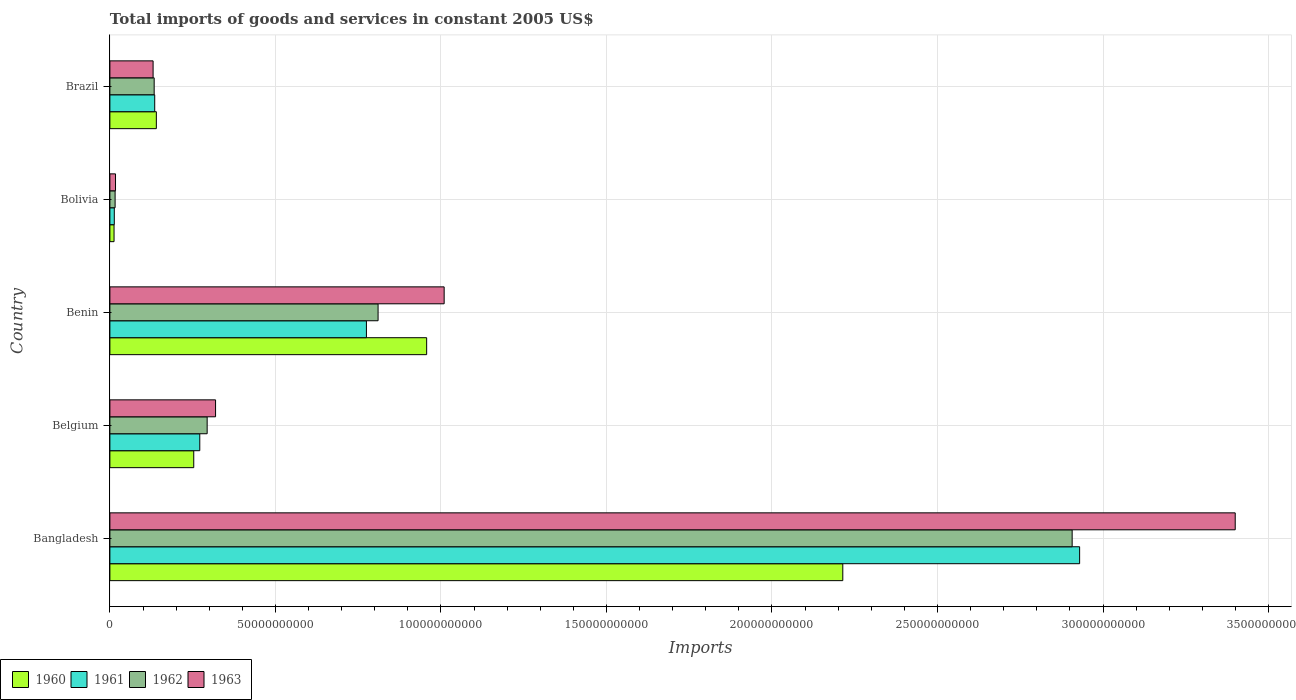How many different coloured bars are there?
Your response must be concise. 4. How many bars are there on the 2nd tick from the bottom?
Give a very brief answer. 4. What is the label of the 1st group of bars from the top?
Give a very brief answer. Brazil. What is the total imports of goods and services in 1963 in Brazil?
Make the answer very short. 1.31e+1. Across all countries, what is the maximum total imports of goods and services in 1962?
Your answer should be compact. 2.91e+11. Across all countries, what is the minimum total imports of goods and services in 1961?
Your answer should be compact. 1.33e+09. In which country was the total imports of goods and services in 1962 maximum?
Offer a terse response. Bangladesh. What is the total total imports of goods and services in 1961 in the graph?
Your response must be concise. 4.12e+11. What is the difference between the total imports of goods and services in 1963 in Belgium and that in Brazil?
Offer a terse response. 1.89e+1. What is the difference between the total imports of goods and services in 1961 in Brazil and the total imports of goods and services in 1962 in Belgium?
Provide a short and direct response. -1.58e+1. What is the average total imports of goods and services in 1961 per country?
Ensure brevity in your answer.  8.25e+1. What is the difference between the total imports of goods and services in 1962 and total imports of goods and services in 1961 in Bolivia?
Your response must be concise. 2.45e+08. What is the ratio of the total imports of goods and services in 1963 in Belgium to that in Brazil?
Your answer should be compact. 2.45. Is the total imports of goods and services in 1960 in Bangladesh less than that in Belgium?
Offer a terse response. No. What is the difference between the highest and the second highest total imports of goods and services in 1962?
Make the answer very short. 2.10e+11. What is the difference between the highest and the lowest total imports of goods and services in 1960?
Provide a short and direct response. 2.20e+11. In how many countries, is the total imports of goods and services in 1963 greater than the average total imports of goods and services in 1963 taken over all countries?
Offer a terse response. 2. Is it the case that in every country, the sum of the total imports of goods and services in 1962 and total imports of goods and services in 1961 is greater than the sum of total imports of goods and services in 1963 and total imports of goods and services in 1960?
Your response must be concise. No. What does the 4th bar from the bottom in Belgium represents?
Ensure brevity in your answer.  1963. Is it the case that in every country, the sum of the total imports of goods and services in 1961 and total imports of goods and services in 1962 is greater than the total imports of goods and services in 1960?
Ensure brevity in your answer.  Yes. Are all the bars in the graph horizontal?
Your response must be concise. Yes. How many countries are there in the graph?
Offer a very short reply. 5. What is the difference between two consecutive major ticks on the X-axis?
Provide a short and direct response. 5.00e+1. Does the graph contain any zero values?
Offer a terse response. No. How many legend labels are there?
Your answer should be compact. 4. How are the legend labels stacked?
Provide a succinct answer. Horizontal. What is the title of the graph?
Offer a very short reply. Total imports of goods and services in constant 2005 US$. What is the label or title of the X-axis?
Your response must be concise. Imports. What is the label or title of the Y-axis?
Offer a very short reply. Country. What is the Imports in 1960 in Bangladesh?
Make the answer very short. 2.21e+11. What is the Imports in 1961 in Bangladesh?
Your answer should be very brief. 2.93e+11. What is the Imports of 1962 in Bangladesh?
Offer a very short reply. 2.91e+11. What is the Imports of 1963 in Bangladesh?
Ensure brevity in your answer.  3.40e+11. What is the Imports of 1960 in Belgium?
Your answer should be compact. 2.53e+1. What is the Imports in 1961 in Belgium?
Your response must be concise. 2.72e+1. What is the Imports in 1962 in Belgium?
Ensure brevity in your answer.  2.94e+1. What is the Imports of 1963 in Belgium?
Provide a short and direct response. 3.19e+1. What is the Imports in 1960 in Benin?
Keep it short and to the point. 9.57e+1. What is the Imports in 1961 in Benin?
Offer a very short reply. 7.75e+1. What is the Imports of 1962 in Benin?
Give a very brief answer. 8.10e+1. What is the Imports of 1963 in Benin?
Keep it short and to the point. 1.01e+11. What is the Imports in 1960 in Bolivia?
Give a very brief answer. 1.26e+09. What is the Imports of 1961 in Bolivia?
Your answer should be compact. 1.33e+09. What is the Imports of 1962 in Bolivia?
Your answer should be compact. 1.58e+09. What is the Imports of 1963 in Bolivia?
Keep it short and to the point. 1.70e+09. What is the Imports in 1960 in Brazil?
Make the answer very short. 1.40e+1. What is the Imports in 1961 in Brazil?
Keep it short and to the point. 1.35e+1. What is the Imports of 1962 in Brazil?
Provide a short and direct response. 1.34e+1. What is the Imports of 1963 in Brazil?
Keep it short and to the point. 1.31e+1. Across all countries, what is the maximum Imports in 1960?
Your response must be concise. 2.21e+11. Across all countries, what is the maximum Imports of 1961?
Provide a short and direct response. 2.93e+11. Across all countries, what is the maximum Imports in 1962?
Ensure brevity in your answer.  2.91e+11. Across all countries, what is the maximum Imports of 1963?
Offer a terse response. 3.40e+11. Across all countries, what is the minimum Imports in 1960?
Ensure brevity in your answer.  1.26e+09. Across all countries, what is the minimum Imports of 1961?
Your answer should be very brief. 1.33e+09. Across all countries, what is the minimum Imports of 1962?
Provide a short and direct response. 1.58e+09. Across all countries, what is the minimum Imports of 1963?
Make the answer very short. 1.70e+09. What is the total Imports of 1960 in the graph?
Provide a short and direct response. 3.58e+11. What is the total Imports in 1961 in the graph?
Offer a very short reply. 4.12e+11. What is the total Imports in 1962 in the graph?
Offer a terse response. 4.16e+11. What is the total Imports of 1963 in the graph?
Your response must be concise. 4.88e+11. What is the difference between the Imports in 1960 in Bangladesh and that in Belgium?
Keep it short and to the point. 1.96e+11. What is the difference between the Imports in 1961 in Bangladesh and that in Belgium?
Make the answer very short. 2.66e+11. What is the difference between the Imports in 1962 in Bangladesh and that in Belgium?
Offer a terse response. 2.61e+11. What is the difference between the Imports of 1963 in Bangladesh and that in Belgium?
Your answer should be very brief. 3.08e+11. What is the difference between the Imports in 1960 in Bangladesh and that in Benin?
Your answer should be compact. 1.26e+11. What is the difference between the Imports in 1961 in Bangladesh and that in Benin?
Make the answer very short. 2.15e+11. What is the difference between the Imports of 1962 in Bangladesh and that in Benin?
Your answer should be compact. 2.10e+11. What is the difference between the Imports in 1963 in Bangladesh and that in Benin?
Offer a very short reply. 2.39e+11. What is the difference between the Imports in 1960 in Bangladesh and that in Bolivia?
Offer a terse response. 2.20e+11. What is the difference between the Imports in 1961 in Bangladesh and that in Bolivia?
Your response must be concise. 2.92e+11. What is the difference between the Imports in 1962 in Bangladesh and that in Bolivia?
Provide a succinct answer. 2.89e+11. What is the difference between the Imports in 1963 in Bangladesh and that in Bolivia?
Provide a short and direct response. 3.38e+11. What is the difference between the Imports of 1960 in Bangladesh and that in Brazil?
Keep it short and to the point. 2.07e+11. What is the difference between the Imports of 1961 in Bangladesh and that in Brazil?
Make the answer very short. 2.79e+11. What is the difference between the Imports of 1962 in Bangladesh and that in Brazil?
Make the answer very short. 2.77e+11. What is the difference between the Imports of 1963 in Bangladesh and that in Brazil?
Offer a very short reply. 3.27e+11. What is the difference between the Imports of 1960 in Belgium and that in Benin?
Offer a terse response. -7.04e+1. What is the difference between the Imports of 1961 in Belgium and that in Benin?
Keep it short and to the point. -5.03e+1. What is the difference between the Imports in 1962 in Belgium and that in Benin?
Offer a terse response. -5.16e+1. What is the difference between the Imports in 1963 in Belgium and that in Benin?
Provide a short and direct response. -6.90e+1. What is the difference between the Imports in 1960 in Belgium and that in Bolivia?
Your answer should be very brief. 2.41e+1. What is the difference between the Imports of 1961 in Belgium and that in Bolivia?
Offer a terse response. 2.58e+1. What is the difference between the Imports in 1962 in Belgium and that in Bolivia?
Ensure brevity in your answer.  2.78e+1. What is the difference between the Imports in 1963 in Belgium and that in Bolivia?
Keep it short and to the point. 3.02e+1. What is the difference between the Imports in 1960 in Belgium and that in Brazil?
Your response must be concise. 1.13e+1. What is the difference between the Imports in 1961 in Belgium and that in Brazil?
Provide a short and direct response. 1.36e+1. What is the difference between the Imports in 1962 in Belgium and that in Brazil?
Make the answer very short. 1.60e+1. What is the difference between the Imports of 1963 in Belgium and that in Brazil?
Provide a succinct answer. 1.89e+1. What is the difference between the Imports of 1960 in Benin and that in Bolivia?
Offer a terse response. 9.44e+1. What is the difference between the Imports in 1961 in Benin and that in Bolivia?
Ensure brevity in your answer.  7.62e+1. What is the difference between the Imports of 1962 in Benin and that in Bolivia?
Keep it short and to the point. 7.94e+1. What is the difference between the Imports in 1963 in Benin and that in Bolivia?
Your answer should be compact. 9.93e+1. What is the difference between the Imports in 1960 in Benin and that in Brazil?
Ensure brevity in your answer.  8.17e+1. What is the difference between the Imports in 1961 in Benin and that in Brazil?
Offer a very short reply. 6.39e+1. What is the difference between the Imports in 1962 in Benin and that in Brazil?
Offer a terse response. 6.76e+1. What is the difference between the Imports of 1963 in Benin and that in Brazil?
Your answer should be very brief. 8.79e+1. What is the difference between the Imports of 1960 in Bolivia and that in Brazil?
Your answer should be compact. -1.28e+1. What is the difference between the Imports of 1961 in Bolivia and that in Brazil?
Provide a succinct answer. -1.22e+1. What is the difference between the Imports in 1962 in Bolivia and that in Brazil?
Ensure brevity in your answer.  -1.18e+1. What is the difference between the Imports in 1963 in Bolivia and that in Brazil?
Your response must be concise. -1.14e+1. What is the difference between the Imports in 1960 in Bangladesh and the Imports in 1961 in Belgium?
Give a very brief answer. 1.94e+11. What is the difference between the Imports of 1960 in Bangladesh and the Imports of 1962 in Belgium?
Provide a short and direct response. 1.92e+11. What is the difference between the Imports in 1960 in Bangladesh and the Imports in 1963 in Belgium?
Your answer should be compact. 1.89e+11. What is the difference between the Imports in 1961 in Bangladesh and the Imports in 1962 in Belgium?
Offer a very short reply. 2.64e+11. What is the difference between the Imports in 1961 in Bangladesh and the Imports in 1963 in Belgium?
Offer a terse response. 2.61e+11. What is the difference between the Imports of 1962 in Bangladesh and the Imports of 1963 in Belgium?
Offer a terse response. 2.59e+11. What is the difference between the Imports in 1960 in Bangladesh and the Imports in 1961 in Benin?
Make the answer very short. 1.44e+11. What is the difference between the Imports of 1960 in Bangladesh and the Imports of 1962 in Benin?
Your response must be concise. 1.40e+11. What is the difference between the Imports of 1960 in Bangladesh and the Imports of 1963 in Benin?
Provide a short and direct response. 1.20e+11. What is the difference between the Imports of 1961 in Bangladesh and the Imports of 1962 in Benin?
Offer a very short reply. 2.12e+11. What is the difference between the Imports of 1961 in Bangladesh and the Imports of 1963 in Benin?
Keep it short and to the point. 1.92e+11. What is the difference between the Imports of 1962 in Bangladesh and the Imports of 1963 in Benin?
Offer a very short reply. 1.90e+11. What is the difference between the Imports of 1960 in Bangladesh and the Imports of 1961 in Bolivia?
Provide a succinct answer. 2.20e+11. What is the difference between the Imports of 1960 in Bangladesh and the Imports of 1962 in Bolivia?
Provide a succinct answer. 2.20e+11. What is the difference between the Imports of 1960 in Bangladesh and the Imports of 1963 in Bolivia?
Your answer should be compact. 2.20e+11. What is the difference between the Imports in 1961 in Bangladesh and the Imports in 1962 in Bolivia?
Keep it short and to the point. 2.91e+11. What is the difference between the Imports in 1961 in Bangladesh and the Imports in 1963 in Bolivia?
Keep it short and to the point. 2.91e+11. What is the difference between the Imports in 1962 in Bangladesh and the Imports in 1963 in Bolivia?
Offer a terse response. 2.89e+11. What is the difference between the Imports of 1960 in Bangladesh and the Imports of 1961 in Brazil?
Make the answer very short. 2.08e+11. What is the difference between the Imports of 1960 in Bangladesh and the Imports of 1962 in Brazil?
Offer a very short reply. 2.08e+11. What is the difference between the Imports of 1960 in Bangladesh and the Imports of 1963 in Brazil?
Ensure brevity in your answer.  2.08e+11. What is the difference between the Imports of 1961 in Bangladesh and the Imports of 1962 in Brazil?
Provide a succinct answer. 2.80e+11. What is the difference between the Imports of 1961 in Bangladesh and the Imports of 1963 in Brazil?
Give a very brief answer. 2.80e+11. What is the difference between the Imports in 1962 in Bangladesh and the Imports in 1963 in Brazil?
Provide a short and direct response. 2.78e+11. What is the difference between the Imports of 1960 in Belgium and the Imports of 1961 in Benin?
Your answer should be compact. -5.22e+1. What is the difference between the Imports in 1960 in Belgium and the Imports in 1962 in Benin?
Keep it short and to the point. -5.57e+1. What is the difference between the Imports in 1960 in Belgium and the Imports in 1963 in Benin?
Your answer should be compact. -7.56e+1. What is the difference between the Imports of 1961 in Belgium and the Imports of 1962 in Benin?
Your answer should be compact. -5.39e+1. What is the difference between the Imports in 1961 in Belgium and the Imports in 1963 in Benin?
Keep it short and to the point. -7.38e+1. What is the difference between the Imports in 1962 in Belgium and the Imports in 1963 in Benin?
Keep it short and to the point. -7.16e+1. What is the difference between the Imports of 1960 in Belgium and the Imports of 1961 in Bolivia?
Keep it short and to the point. 2.40e+1. What is the difference between the Imports in 1960 in Belgium and the Imports in 1962 in Bolivia?
Provide a succinct answer. 2.38e+1. What is the difference between the Imports of 1960 in Belgium and the Imports of 1963 in Bolivia?
Provide a short and direct response. 2.36e+1. What is the difference between the Imports in 1961 in Belgium and the Imports in 1962 in Bolivia?
Your answer should be very brief. 2.56e+1. What is the difference between the Imports of 1961 in Belgium and the Imports of 1963 in Bolivia?
Offer a terse response. 2.55e+1. What is the difference between the Imports in 1962 in Belgium and the Imports in 1963 in Bolivia?
Keep it short and to the point. 2.77e+1. What is the difference between the Imports of 1960 in Belgium and the Imports of 1961 in Brazil?
Offer a terse response. 1.18e+1. What is the difference between the Imports of 1960 in Belgium and the Imports of 1962 in Brazil?
Provide a short and direct response. 1.20e+1. What is the difference between the Imports of 1960 in Belgium and the Imports of 1963 in Brazil?
Your answer should be very brief. 1.23e+1. What is the difference between the Imports of 1961 in Belgium and the Imports of 1962 in Brazil?
Give a very brief answer. 1.38e+1. What is the difference between the Imports of 1961 in Belgium and the Imports of 1963 in Brazil?
Keep it short and to the point. 1.41e+1. What is the difference between the Imports of 1962 in Belgium and the Imports of 1963 in Brazil?
Provide a short and direct response. 1.63e+1. What is the difference between the Imports of 1960 in Benin and the Imports of 1961 in Bolivia?
Offer a very short reply. 9.44e+1. What is the difference between the Imports in 1960 in Benin and the Imports in 1962 in Bolivia?
Keep it short and to the point. 9.41e+1. What is the difference between the Imports of 1960 in Benin and the Imports of 1963 in Bolivia?
Keep it short and to the point. 9.40e+1. What is the difference between the Imports of 1961 in Benin and the Imports of 1962 in Bolivia?
Provide a short and direct response. 7.59e+1. What is the difference between the Imports of 1961 in Benin and the Imports of 1963 in Bolivia?
Give a very brief answer. 7.58e+1. What is the difference between the Imports in 1962 in Benin and the Imports in 1963 in Bolivia?
Provide a succinct answer. 7.93e+1. What is the difference between the Imports of 1960 in Benin and the Imports of 1961 in Brazil?
Offer a very short reply. 8.21e+1. What is the difference between the Imports in 1960 in Benin and the Imports in 1962 in Brazil?
Give a very brief answer. 8.23e+1. What is the difference between the Imports in 1960 in Benin and the Imports in 1963 in Brazil?
Give a very brief answer. 8.26e+1. What is the difference between the Imports in 1961 in Benin and the Imports in 1962 in Brazil?
Your answer should be compact. 6.41e+1. What is the difference between the Imports of 1961 in Benin and the Imports of 1963 in Brazil?
Your response must be concise. 6.44e+1. What is the difference between the Imports of 1962 in Benin and the Imports of 1963 in Brazil?
Give a very brief answer. 6.80e+1. What is the difference between the Imports in 1960 in Bolivia and the Imports in 1961 in Brazil?
Your answer should be compact. -1.23e+1. What is the difference between the Imports of 1960 in Bolivia and the Imports of 1962 in Brazil?
Give a very brief answer. -1.21e+1. What is the difference between the Imports in 1960 in Bolivia and the Imports in 1963 in Brazil?
Give a very brief answer. -1.18e+1. What is the difference between the Imports of 1961 in Bolivia and the Imports of 1962 in Brazil?
Give a very brief answer. -1.20e+1. What is the difference between the Imports of 1961 in Bolivia and the Imports of 1963 in Brazil?
Your answer should be very brief. -1.17e+1. What is the difference between the Imports of 1962 in Bolivia and the Imports of 1963 in Brazil?
Offer a very short reply. -1.15e+1. What is the average Imports in 1960 per country?
Offer a terse response. 7.15e+1. What is the average Imports of 1961 per country?
Ensure brevity in your answer.  8.25e+1. What is the average Imports of 1962 per country?
Your response must be concise. 8.32e+1. What is the average Imports in 1963 per country?
Provide a short and direct response. 9.75e+1. What is the difference between the Imports in 1960 and Imports in 1961 in Bangladesh?
Make the answer very short. -7.15e+1. What is the difference between the Imports of 1960 and Imports of 1962 in Bangladesh?
Give a very brief answer. -6.93e+1. What is the difference between the Imports of 1960 and Imports of 1963 in Bangladesh?
Keep it short and to the point. -1.19e+11. What is the difference between the Imports in 1961 and Imports in 1962 in Bangladesh?
Offer a very short reply. 2.26e+09. What is the difference between the Imports of 1961 and Imports of 1963 in Bangladesh?
Offer a terse response. -4.70e+1. What is the difference between the Imports of 1962 and Imports of 1963 in Bangladesh?
Offer a terse response. -4.93e+1. What is the difference between the Imports in 1960 and Imports in 1961 in Belgium?
Give a very brief answer. -1.82e+09. What is the difference between the Imports of 1960 and Imports of 1962 in Belgium?
Ensure brevity in your answer.  -4.05e+09. What is the difference between the Imports of 1960 and Imports of 1963 in Belgium?
Make the answer very short. -6.59e+09. What is the difference between the Imports of 1961 and Imports of 1962 in Belgium?
Your response must be concise. -2.23e+09. What is the difference between the Imports of 1961 and Imports of 1963 in Belgium?
Keep it short and to the point. -4.77e+09. What is the difference between the Imports in 1962 and Imports in 1963 in Belgium?
Provide a succinct answer. -2.54e+09. What is the difference between the Imports in 1960 and Imports in 1961 in Benin?
Offer a terse response. 1.82e+1. What is the difference between the Imports in 1960 and Imports in 1962 in Benin?
Provide a succinct answer. 1.47e+1. What is the difference between the Imports in 1960 and Imports in 1963 in Benin?
Provide a succinct answer. -5.28e+09. What is the difference between the Imports in 1961 and Imports in 1962 in Benin?
Provide a short and direct response. -3.52e+09. What is the difference between the Imports of 1961 and Imports of 1963 in Benin?
Offer a very short reply. -2.35e+1. What is the difference between the Imports of 1962 and Imports of 1963 in Benin?
Ensure brevity in your answer.  -2.00e+1. What is the difference between the Imports in 1960 and Imports in 1961 in Bolivia?
Your response must be concise. -7.36e+07. What is the difference between the Imports in 1960 and Imports in 1962 in Bolivia?
Provide a short and direct response. -3.19e+08. What is the difference between the Imports in 1960 and Imports in 1963 in Bolivia?
Offer a very short reply. -4.41e+08. What is the difference between the Imports of 1961 and Imports of 1962 in Bolivia?
Give a very brief answer. -2.45e+08. What is the difference between the Imports of 1961 and Imports of 1963 in Bolivia?
Your response must be concise. -3.67e+08. What is the difference between the Imports in 1962 and Imports in 1963 in Bolivia?
Provide a short and direct response. -1.22e+08. What is the difference between the Imports in 1960 and Imports in 1961 in Brazil?
Make the answer very short. 4.89e+08. What is the difference between the Imports of 1960 and Imports of 1962 in Brazil?
Provide a succinct answer. 6.53e+08. What is the difference between the Imports in 1960 and Imports in 1963 in Brazil?
Offer a very short reply. 9.79e+08. What is the difference between the Imports in 1961 and Imports in 1962 in Brazil?
Make the answer very short. 1.63e+08. What is the difference between the Imports of 1961 and Imports of 1963 in Brazil?
Your response must be concise. 4.89e+08. What is the difference between the Imports of 1962 and Imports of 1963 in Brazil?
Keep it short and to the point. 3.26e+08. What is the ratio of the Imports of 1960 in Bangladesh to that in Belgium?
Your answer should be very brief. 8.74. What is the ratio of the Imports in 1961 in Bangladesh to that in Belgium?
Your answer should be compact. 10.79. What is the ratio of the Imports of 1962 in Bangladesh to that in Belgium?
Offer a very short reply. 9.89. What is the ratio of the Imports in 1963 in Bangladesh to that in Belgium?
Your answer should be compact. 10.65. What is the ratio of the Imports of 1960 in Bangladesh to that in Benin?
Keep it short and to the point. 2.31. What is the ratio of the Imports in 1961 in Bangladesh to that in Benin?
Provide a succinct answer. 3.78. What is the ratio of the Imports of 1962 in Bangladesh to that in Benin?
Provide a succinct answer. 3.59. What is the ratio of the Imports of 1963 in Bangladesh to that in Benin?
Give a very brief answer. 3.37. What is the ratio of the Imports of 1960 in Bangladesh to that in Bolivia?
Offer a terse response. 176.1. What is the ratio of the Imports of 1961 in Bangladesh to that in Bolivia?
Make the answer very short. 220.12. What is the ratio of the Imports in 1962 in Bangladesh to that in Bolivia?
Make the answer very short. 184.42. What is the ratio of the Imports in 1963 in Bangladesh to that in Bolivia?
Keep it short and to the point. 200.23. What is the ratio of the Imports in 1960 in Bangladesh to that in Brazil?
Keep it short and to the point. 15.78. What is the ratio of the Imports in 1961 in Bangladesh to that in Brazil?
Provide a succinct answer. 21.63. What is the ratio of the Imports in 1962 in Bangladesh to that in Brazil?
Give a very brief answer. 21.73. What is the ratio of the Imports of 1963 in Bangladesh to that in Brazil?
Keep it short and to the point. 26.04. What is the ratio of the Imports of 1960 in Belgium to that in Benin?
Offer a terse response. 0.26. What is the ratio of the Imports in 1961 in Belgium to that in Benin?
Offer a very short reply. 0.35. What is the ratio of the Imports in 1962 in Belgium to that in Benin?
Your answer should be compact. 0.36. What is the ratio of the Imports in 1963 in Belgium to that in Benin?
Your answer should be compact. 0.32. What is the ratio of the Imports of 1960 in Belgium to that in Bolivia?
Your answer should be very brief. 20.15. What is the ratio of the Imports of 1961 in Belgium to that in Bolivia?
Offer a terse response. 20.4. What is the ratio of the Imports in 1962 in Belgium to that in Bolivia?
Make the answer very short. 18.64. What is the ratio of the Imports of 1963 in Belgium to that in Bolivia?
Your response must be concise. 18.8. What is the ratio of the Imports of 1960 in Belgium to that in Brazil?
Make the answer very short. 1.81. What is the ratio of the Imports in 1961 in Belgium to that in Brazil?
Your answer should be compact. 2.01. What is the ratio of the Imports of 1962 in Belgium to that in Brazil?
Ensure brevity in your answer.  2.2. What is the ratio of the Imports in 1963 in Belgium to that in Brazil?
Ensure brevity in your answer.  2.45. What is the ratio of the Imports of 1960 in Benin to that in Bolivia?
Ensure brevity in your answer.  76.11. What is the ratio of the Imports in 1961 in Benin to that in Bolivia?
Give a very brief answer. 58.23. What is the ratio of the Imports of 1962 in Benin to that in Bolivia?
Give a very brief answer. 51.4. What is the ratio of the Imports of 1963 in Benin to that in Bolivia?
Your response must be concise. 59.47. What is the ratio of the Imports of 1960 in Benin to that in Brazil?
Keep it short and to the point. 6.82. What is the ratio of the Imports of 1961 in Benin to that in Brazil?
Offer a terse response. 5.72. What is the ratio of the Imports in 1962 in Benin to that in Brazil?
Offer a very short reply. 6.06. What is the ratio of the Imports in 1963 in Benin to that in Brazil?
Your answer should be very brief. 7.74. What is the ratio of the Imports of 1960 in Bolivia to that in Brazil?
Provide a succinct answer. 0.09. What is the ratio of the Imports in 1961 in Bolivia to that in Brazil?
Provide a succinct answer. 0.1. What is the ratio of the Imports of 1962 in Bolivia to that in Brazil?
Make the answer very short. 0.12. What is the ratio of the Imports of 1963 in Bolivia to that in Brazil?
Your answer should be compact. 0.13. What is the difference between the highest and the second highest Imports of 1960?
Your answer should be very brief. 1.26e+11. What is the difference between the highest and the second highest Imports of 1961?
Your answer should be compact. 2.15e+11. What is the difference between the highest and the second highest Imports in 1962?
Provide a succinct answer. 2.10e+11. What is the difference between the highest and the second highest Imports of 1963?
Ensure brevity in your answer.  2.39e+11. What is the difference between the highest and the lowest Imports of 1960?
Your answer should be very brief. 2.20e+11. What is the difference between the highest and the lowest Imports of 1961?
Provide a succinct answer. 2.92e+11. What is the difference between the highest and the lowest Imports in 1962?
Your response must be concise. 2.89e+11. What is the difference between the highest and the lowest Imports of 1963?
Your response must be concise. 3.38e+11. 